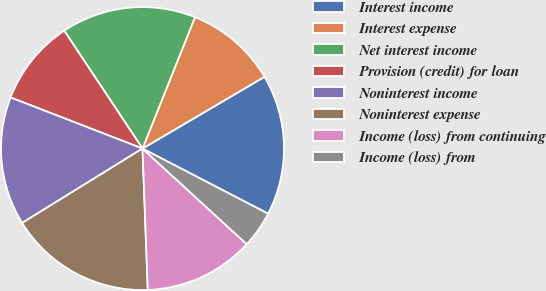Convert chart to OTSL. <chart><loc_0><loc_0><loc_500><loc_500><pie_chart><fcel>Interest income<fcel>Interest expense<fcel>Net interest income<fcel>Provision (credit) for loan<fcel>Noninterest income<fcel>Noninterest expense<fcel>Income (loss) from continuing<fcel>Income (loss) from<nl><fcel>16.08%<fcel>10.49%<fcel>15.38%<fcel>9.79%<fcel>14.69%<fcel>16.78%<fcel>12.59%<fcel>4.2%<nl></chart> 